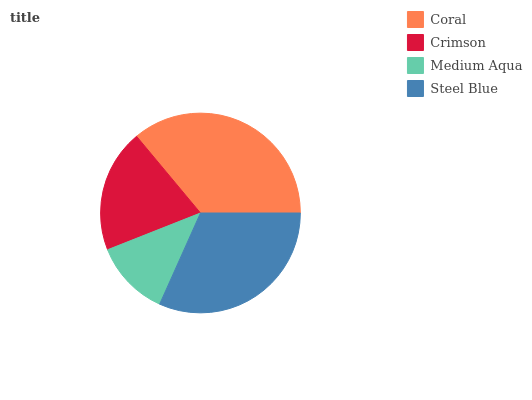Is Medium Aqua the minimum?
Answer yes or no. Yes. Is Coral the maximum?
Answer yes or no. Yes. Is Crimson the minimum?
Answer yes or no. No. Is Crimson the maximum?
Answer yes or no. No. Is Coral greater than Crimson?
Answer yes or no. Yes. Is Crimson less than Coral?
Answer yes or no. Yes. Is Crimson greater than Coral?
Answer yes or no. No. Is Coral less than Crimson?
Answer yes or no. No. Is Steel Blue the high median?
Answer yes or no. Yes. Is Crimson the low median?
Answer yes or no. Yes. Is Medium Aqua the high median?
Answer yes or no. No. Is Medium Aqua the low median?
Answer yes or no. No. 